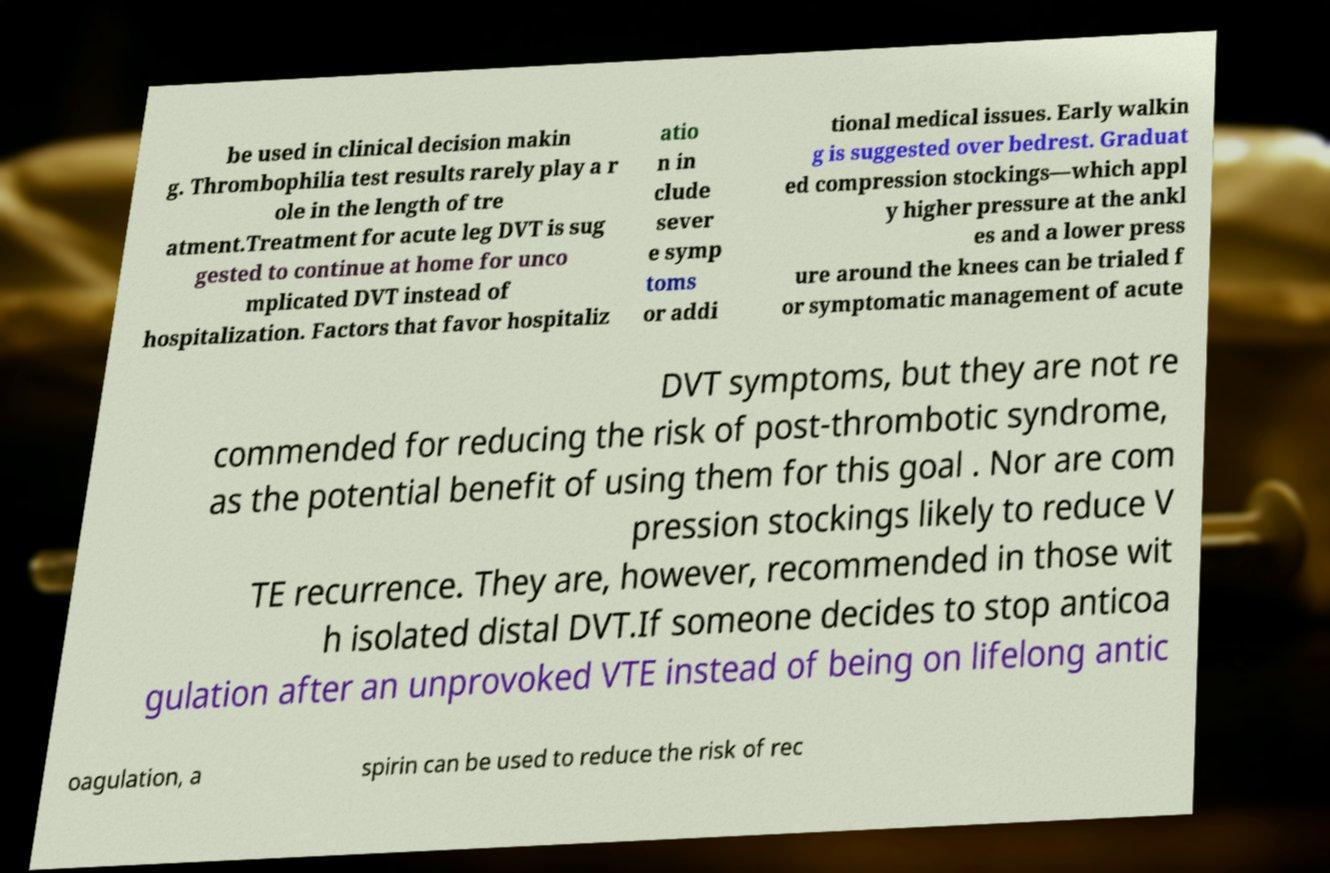Please read and relay the text visible in this image. What does it say? be used in clinical decision makin g. Thrombophilia test results rarely play a r ole in the length of tre atment.Treatment for acute leg DVT is sug gested to continue at home for unco mplicated DVT instead of hospitalization. Factors that favor hospitaliz atio n in clude sever e symp toms or addi tional medical issues. Early walkin g is suggested over bedrest. Graduat ed compression stockings—which appl y higher pressure at the ankl es and a lower press ure around the knees can be trialed f or symptomatic management of acute DVT symptoms, but they are not re commended for reducing the risk of post-thrombotic syndrome, as the potential benefit of using them for this goal . Nor are com pression stockings likely to reduce V TE recurrence. They are, however, recommended in those wit h isolated distal DVT.If someone decides to stop anticoa gulation after an unprovoked VTE instead of being on lifelong antic oagulation, a spirin can be used to reduce the risk of rec 